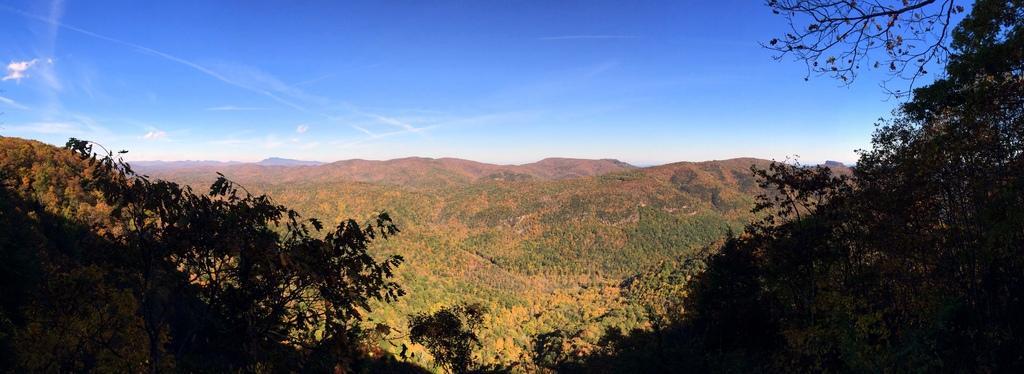Please provide a concise description of this image. This picture is taken from outside of the city. In this image, we can see some trees, rocks, mountains. At the top, we can see a sky. 